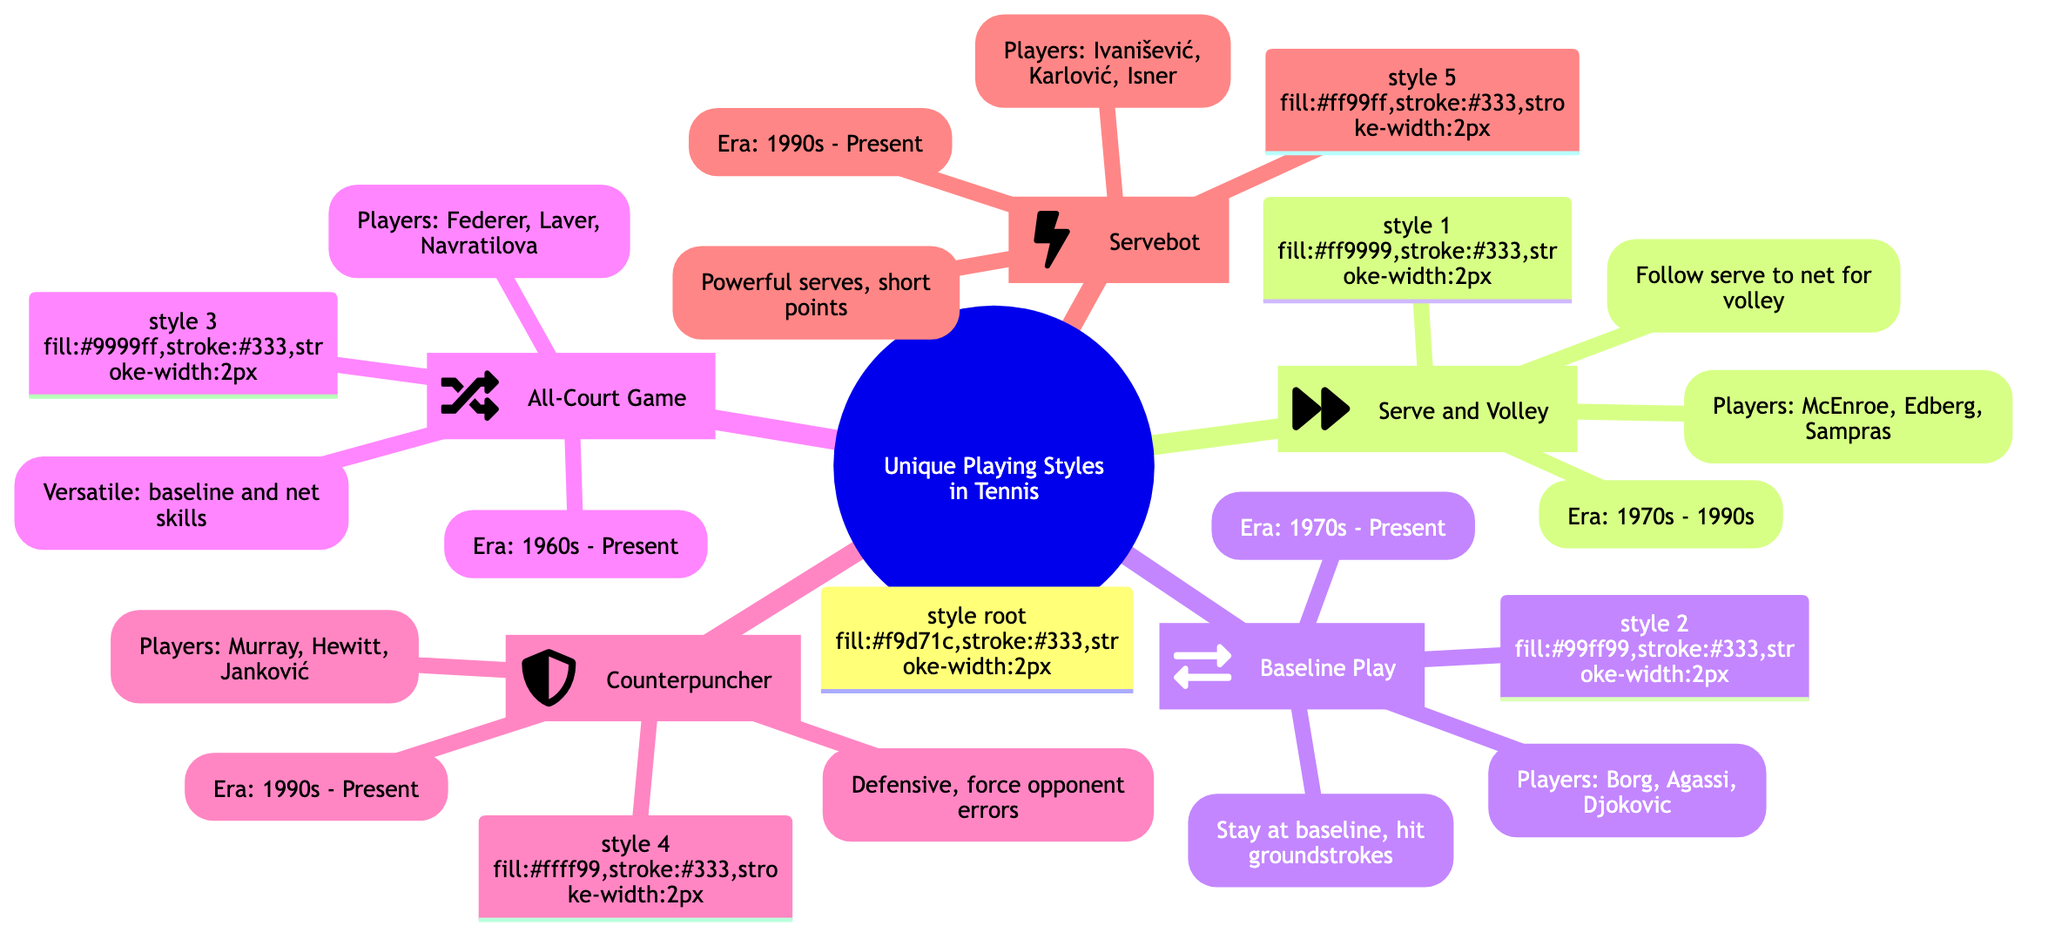What is the main title of the mind map? The mind map is titled "Unique Playing Styles in Tennis: A Journey through History" as indicated at the root node of the diagram.
Answer: Unique Playing Styles in Tennis: A Journey through History How many unique playing styles are represented in the diagram? There are five branches stemming from the root, each representing a unique playing style, indicating that the diagram contains five unique playing styles.
Answer: 5 Which playing style is associated with the era 1970s - Present? The playing style "Baseline Play" is listed under the era of 1970s - Present, as seen in its specific section of the diagram.
Answer: Baseline Play Who is a notable player of the "Counterpuncher" style? Lleyton Hewitt is mentioned as one of the notable players within the "Counterpuncher" section, according to the information provided in the diagram.
Answer: Lleyton Hewitt What is the key characteristic of the "Serve and Volley" style? The key characteristic of the "Serve and Volley" style is described as "Follow serve to net for volley," which summarizes the player's strategy in this style.
Answer: Follow serve to net for volley Identify a playing style that has notable players from the 1990s to Present. Both the "Counterpuncher" and "Servebot" styles include notable players from the 1990s to Present, as indicated by the eras noted under those branches in the mind map.
Answer: Counterpuncher, Servebot Which player is specifically associated with the "Servebot" playing style? John Isner is listed as a notable player in the "Servebot" category, highlighted in the relevant section of the diagram.
Answer: John Isner How does the "All-Court Game" style differ from "Baseline Play"? The "All-Court Game" is described as "Versatile: baseline and net skills," whereas "Baseline Play" is specified as "Stay at baseline, hit groundstrokes," indicating the former's flexibility in gameplay.
Answer: Versatile: baseline and net skills What is the significance of the icon next to "Serve and Volley"? The icon next to "Serve and Volley" is a forward arrow, which symbolizes the action of serving and following the serve into the net, emphasizing the dynamic nature of this playing style.
Answer: Forward arrow 